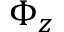Convert formula to latex. <formula><loc_0><loc_0><loc_500><loc_500>\Phi _ { z }</formula> 